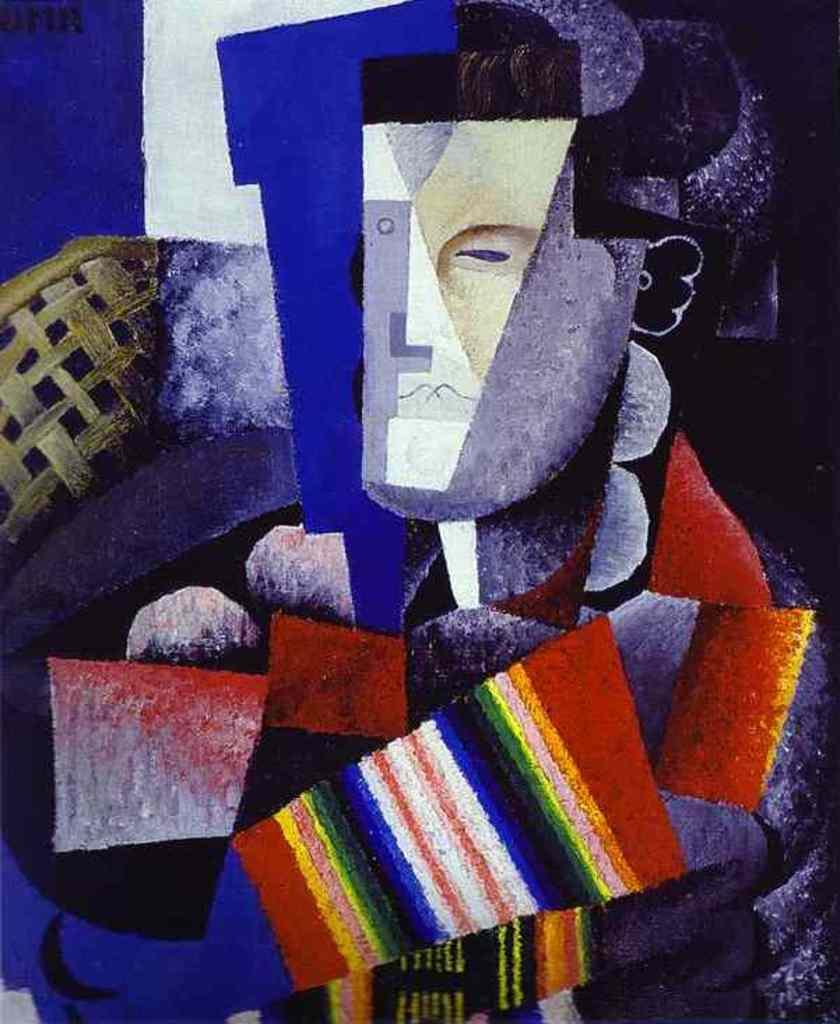What is the main subject of the painting in the image? There is a painting of a person in the image. What type of cart is being used by the person in the painting? There is no cart present in the painting; it only features a person. What utensil is the person holding in the painting? The painting does not depict the person holding any utensils, such as a fork. 